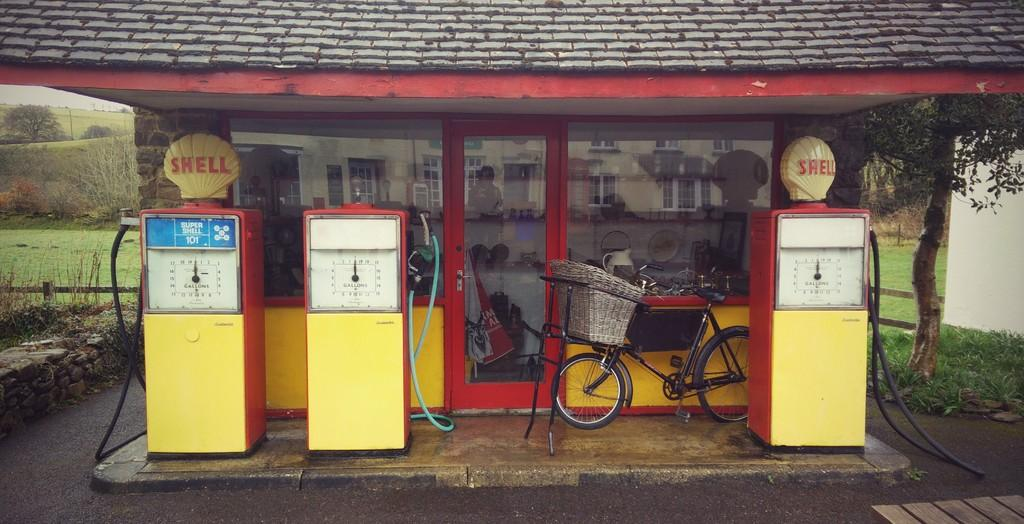What type of establishment is depicted in the image? There is a gas filling station in the image. What mode of transportation can be seen in the image? There is a bicycle in the image. What feature of the building is visible in the image? There is a glass door with a reflection of a building. What type of natural environment is visible in the background of the image? There are trees in the background of the image. What type of hobbies can be seen being practiced on the sofa in the image? There is no sofa present in the image, and therefore no hobbies can be observed being practiced on it. 